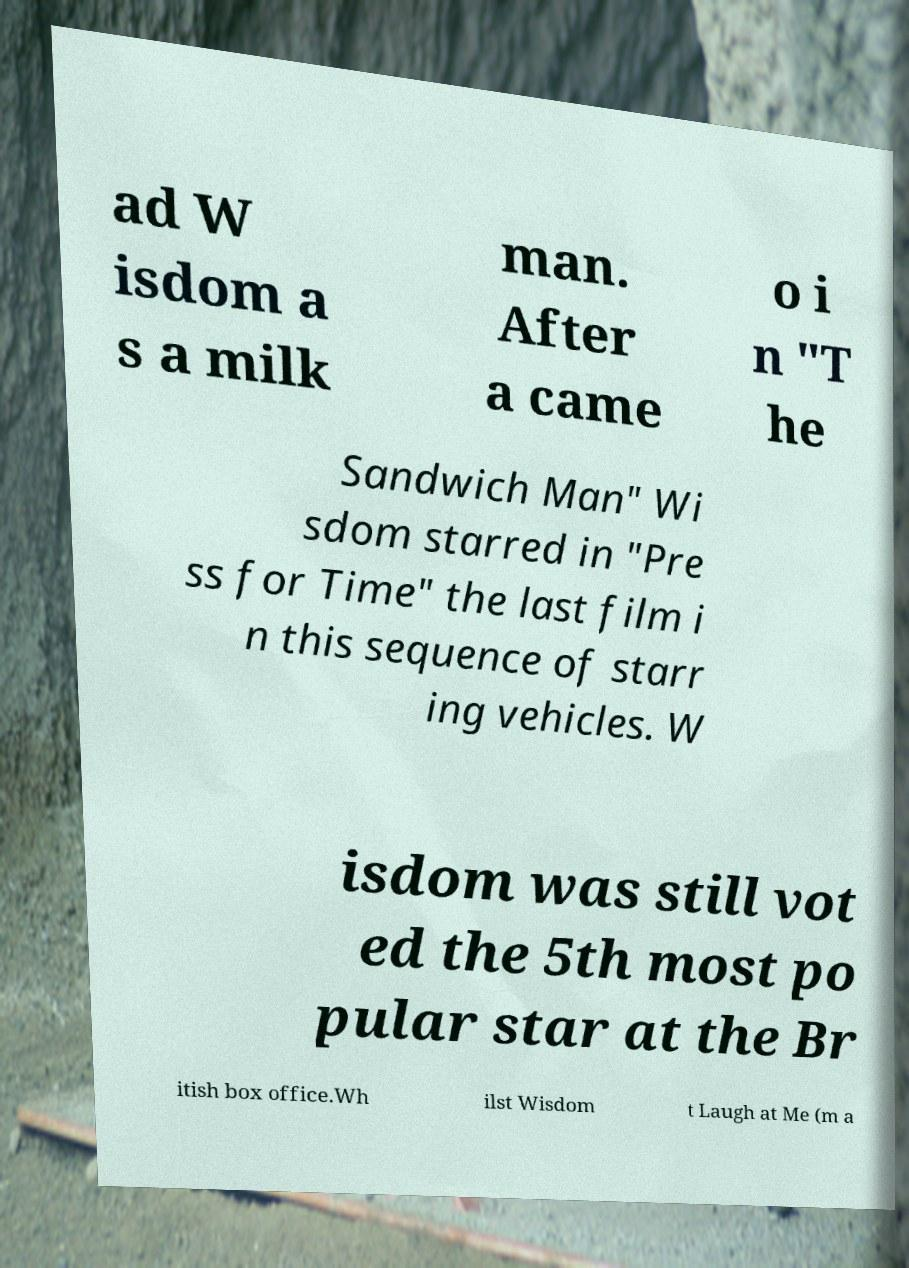Could you assist in decoding the text presented in this image and type it out clearly? ad W isdom a s a milk man. After a came o i n "T he Sandwich Man" Wi sdom starred in "Pre ss for Time" the last film i n this sequence of starr ing vehicles. W isdom was still vot ed the 5th most po pular star at the Br itish box office.Wh ilst Wisdom t Laugh at Me (m a 